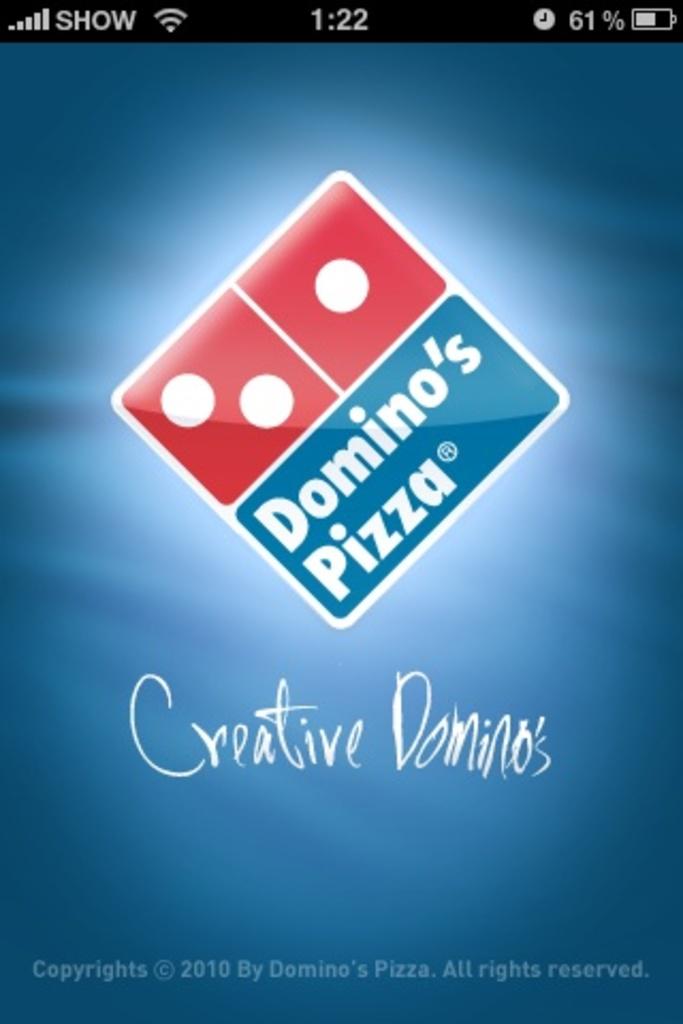What is the pizza company here?
Make the answer very short. Domino's pizza. What food does this company make?
Keep it short and to the point. Pizza. 